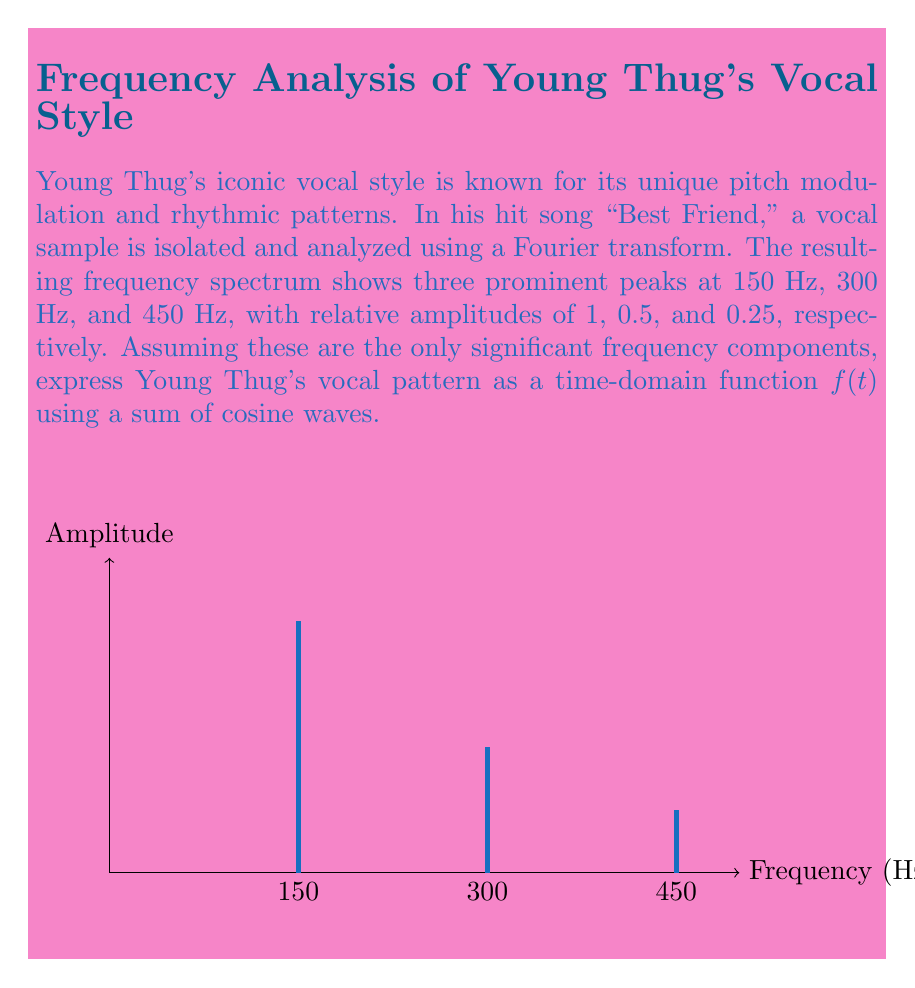Can you answer this question? Let's approach this step-by-step:

1) The general form of a cosine wave is $A \cos(2\pi ft)$, where $A$ is the amplitude, $f$ is the frequency, and $t$ is time.

2) We have three frequency components:
   - 150 Hz with amplitude 1
   - 300 Hz with amplitude 0.5
   - 450 Hz with amplitude 0.25

3) Let's express each component:
   - Component 1: $1 \cos(2\pi \cdot 150t)$
   - Component 2: $0.5 \cos(2\pi \cdot 300t)$
   - Component 3: $0.25 \cos(2\pi \cdot 450t)$

4) The time-domain function $f(t)$ is the sum of these components:

   $$f(t) = 1 \cos(2\pi \cdot 150t) + 0.5 \cos(2\pi \cdot 300t) + 0.25 \cos(2\pi \cdot 450t)$$

5) We can simplify this by factoring out $2\pi$:

   $$f(t) = \cos(300\pi t) + 0.5 \cos(600\pi t) + 0.25 \cos(900\pi t)$$

This function represents Young Thug's vocal pattern in the time domain based on the given frequency components.
Answer: $$f(t) = \cos(300\pi t) + 0.5 \cos(600\pi t) + 0.25 \cos(900\pi t)$$ 